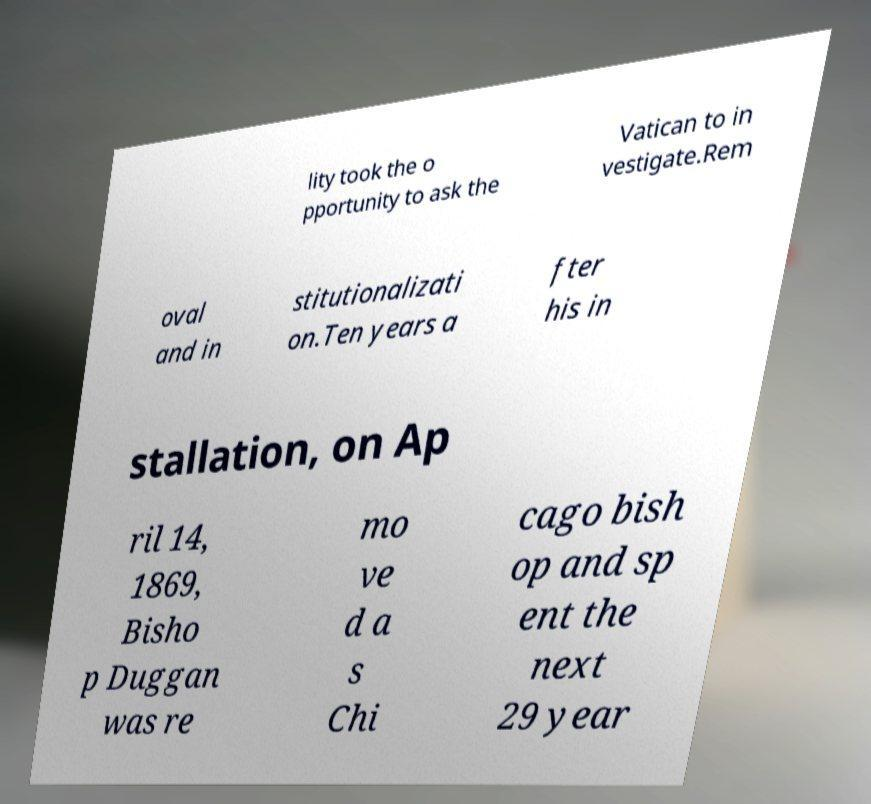I need the written content from this picture converted into text. Can you do that? lity took the o pportunity to ask the Vatican to in vestigate.Rem oval and in stitutionalizati on.Ten years a fter his in stallation, on Ap ril 14, 1869, Bisho p Duggan was re mo ve d a s Chi cago bish op and sp ent the next 29 year 